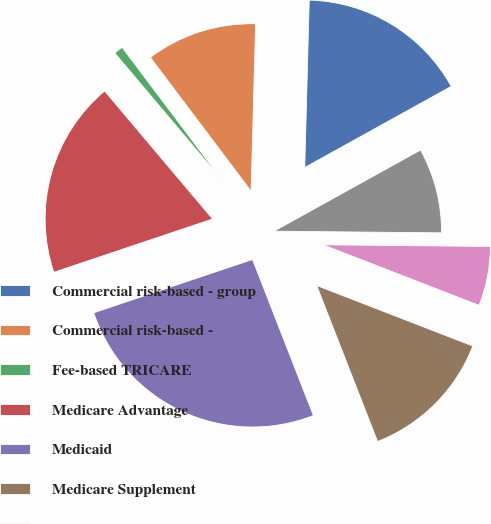Convert chart to OTSL. <chart><loc_0><loc_0><loc_500><loc_500><pie_chart><fcel>Commercial risk-based - group<fcel>Commercial risk-based -<fcel>Fee-based TRICARE<fcel>Medicare Advantage<fcel>Medicaid<fcel>Medicare Supplement<fcel>International<fcel>Medicare Part D stand-alone<nl><fcel>16.52%<fcel>10.7%<fcel>0.88%<fcel>19.0%<fcel>25.77%<fcel>13.19%<fcel>5.73%<fcel>8.21%<nl></chart> 